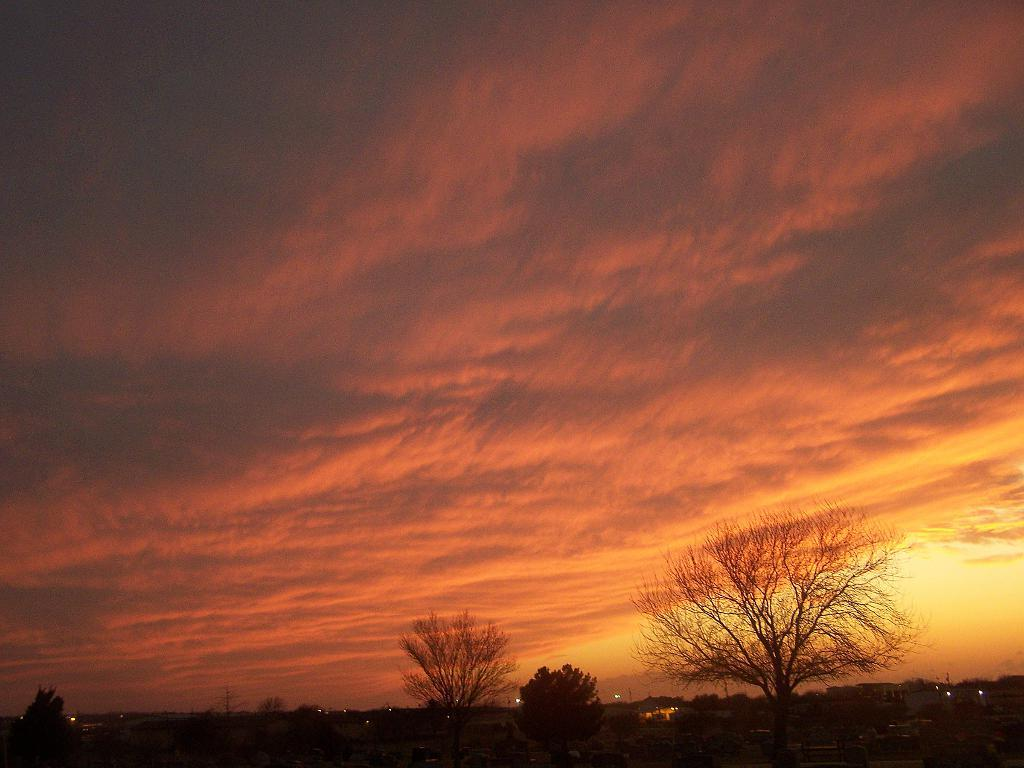What type of natural vegetation can be seen in the image? There are trees in the image. What is located at the bottom of the image? There are lights at the bottom of the image. What part of the natural environment is visible in the image? The sky is visible in the background of the image. How would you describe the weather in the image? The sky is cloudy, which suggests a partly cloudy or overcast day. What type of tank is visible in the image? There is no tank present in the image. What is inside the jar that is visible in the image? There is no jar present in the image. 